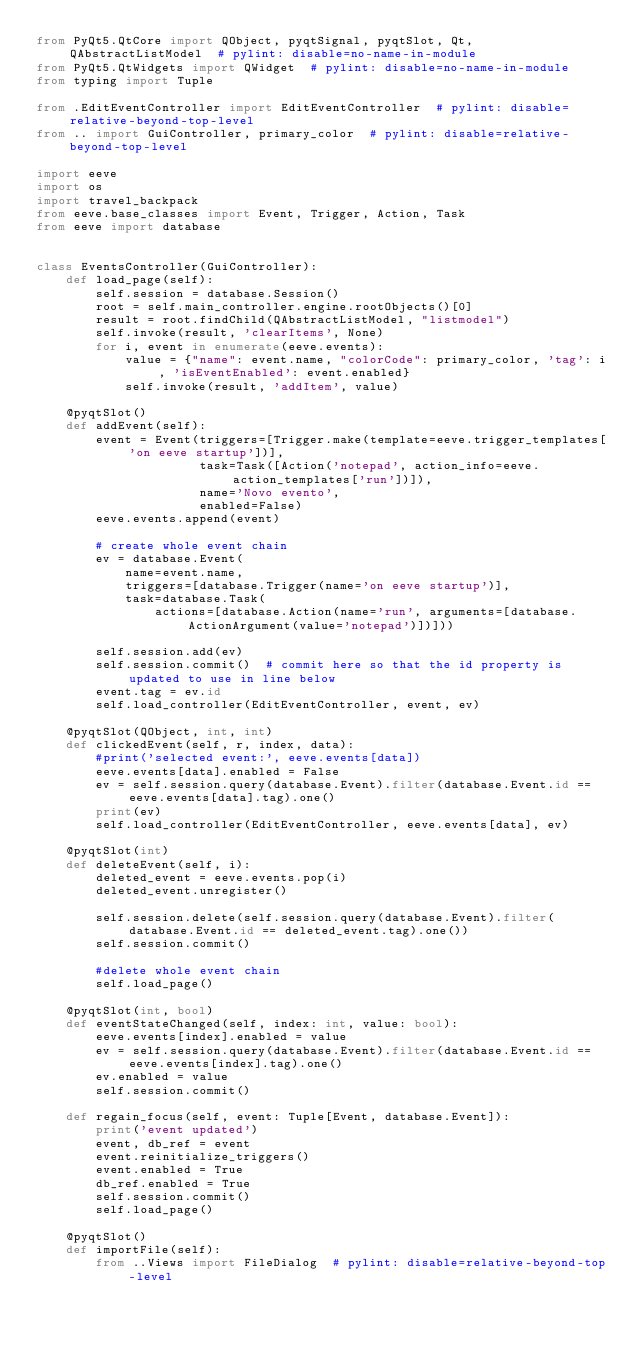<code> <loc_0><loc_0><loc_500><loc_500><_Python_>from PyQt5.QtCore import QObject, pyqtSignal, pyqtSlot, Qt, QAbstractListModel  # pylint: disable=no-name-in-module
from PyQt5.QtWidgets import QWidget  # pylint: disable=no-name-in-module
from typing import Tuple

from .EditEventController import EditEventController  # pylint: disable=relative-beyond-top-level
from .. import GuiController, primary_color  # pylint: disable=relative-beyond-top-level

import eeve
import os
import travel_backpack
from eeve.base_classes import Event, Trigger, Action, Task
from eeve import database


class EventsController(GuiController):
    def load_page(self):
        self.session = database.Session()
        root = self.main_controller.engine.rootObjects()[0]
        result = root.findChild(QAbstractListModel, "listmodel")
        self.invoke(result, 'clearItems', None)
        for i, event in enumerate(eeve.events):
            value = {"name": event.name, "colorCode": primary_color, 'tag': i, 'isEventEnabled': event.enabled}
            self.invoke(result, 'addItem', value)

    @pyqtSlot()
    def addEvent(self):
        event = Event(triggers=[Trigger.make(template=eeve.trigger_templates['on eeve startup'])],
                      task=Task([Action('notepad', action_info=eeve.action_templates['run'])]),
                      name='Novo evento',
                      enabled=False)
        eeve.events.append(event)

        # create whole event chain
        ev = database.Event(
            name=event.name,
            triggers=[database.Trigger(name='on eeve startup')],
            task=database.Task(
                actions=[database.Action(name='run', arguments=[database.ActionArgument(value='notepad')])]))

        self.session.add(ev)
        self.session.commit()  # commit here so that the id property is updated to use in line below
        event.tag = ev.id
        self.load_controller(EditEventController, event, ev)

    @pyqtSlot(QObject, int, int)
    def clickedEvent(self, r, index, data):
        #print('selected event:', eeve.events[data])
        eeve.events[data].enabled = False
        ev = self.session.query(database.Event).filter(database.Event.id == eeve.events[data].tag).one()
        print(ev)
        self.load_controller(EditEventController, eeve.events[data], ev)

    @pyqtSlot(int)
    def deleteEvent(self, i):
        deleted_event = eeve.events.pop(i)
        deleted_event.unregister()

        self.session.delete(self.session.query(database.Event).filter(database.Event.id == deleted_event.tag).one())
        self.session.commit()

        #delete whole event chain
        self.load_page()

    @pyqtSlot(int, bool)
    def eventStateChanged(self, index: int, value: bool):
        eeve.events[index].enabled = value
        ev = self.session.query(database.Event).filter(database.Event.id == eeve.events[index].tag).one()
        ev.enabled = value
        self.session.commit()

    def regain_focus(self, event: Tuple[Event, database.Event]):
        print('event updated')
        event, db_ref = event
        event.reinitialize_triggers()
        event.enabled = True
        db_ref.enabled = True
        self.session.commit()
        self.load_page()

    @pyqtSlot()
    def importFile(self):
        from ..Views import FileDialog  # pylint: disable=relative-beyond-top-level</code> 